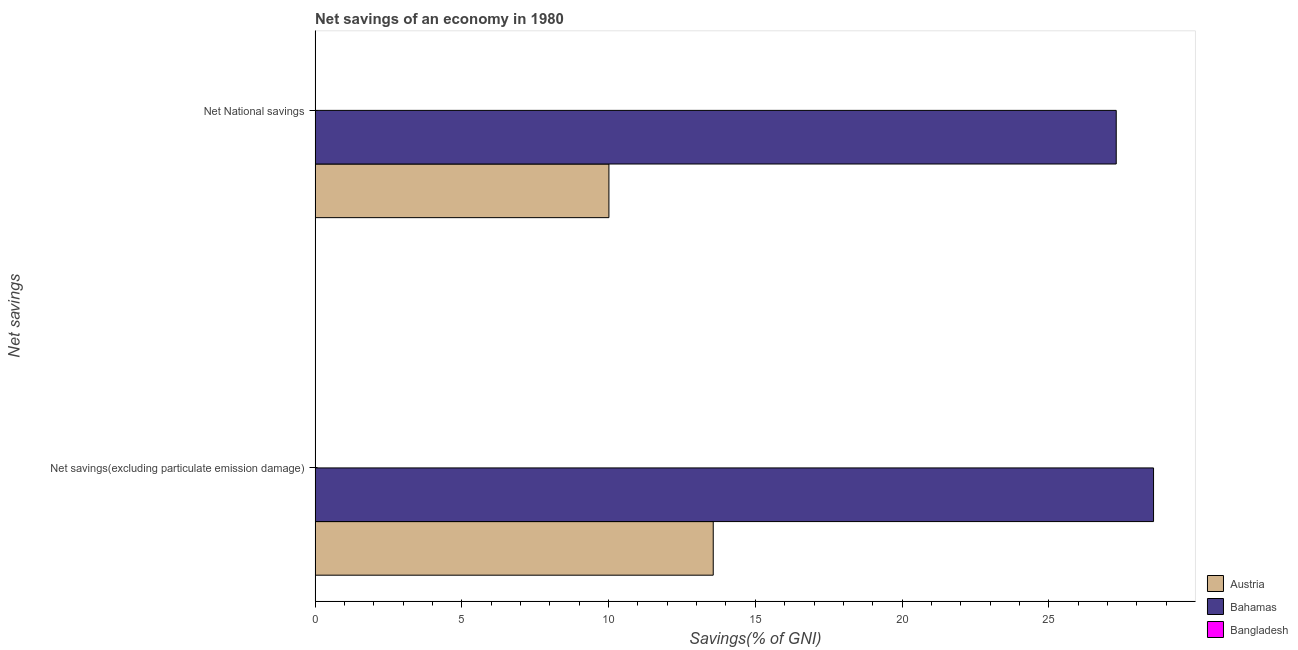Are the number of bars per tick equal to the number of legend labels?
Provide a short and direct response. No. How many bars are there on the 1st tick from the top?
Offer a terse response. 2. How many bars are there on the 1st tick from the bottom?
Your answer should be compact. 2. What is the label of the 1st group of bars from the top?
Provide a short and direct response. Net National savings. What is the net national savings in Austria?
Give a very brief answer. 10.01. Across all countries, what is the maximum net national savings?
Provide a succinct answer. 27.3. In which country was the net national savings maximum?
Your response must be concise. Bahamas. What is the total net savings(excluding particulate emission damage) in the graph?
Offer a very short reply. 42.14. What is the difference between the net national savings in Bahamas and that in Austria?
Your response must be concise. 17.29. What is the difference between the net savings(excluding particulate emission damage) in Bangladesh and the net national savings in Bahamas?
Offer a terse response. -27.3. What is the average net savings(excluding particulate emission damage) per country?
Keep it short and to the point. 14.05. What is the difference between the net savings(excluding particulate emission damage) and net national savings in Bahamas?
Your response must be concise. 1.27. What is the ratio of the net savings(excluding particulate emission damage) in Bahamas to that in Austria?
Your response must be concise. 2.11. Are all the bars in the graph horizontal?
Provide a short and direct response. Yes. How many countries are there in the graph?
Offer a very short reply. 3. What is the difference between two consecutive major ticks on the X-axis?
Provide a short and direct response. 5. Where does the legend appear in the graph?
Your response must be concise. Bottom right. How are the legend labels stacked?
Keep it short and to the point. Vertical. What is the title of the graph?
Keep it short and to the point. Net savings of an economy in 1980. What is the label or title of the X-axis?
Your response must be concise. Savings(% of GNI). What is the label or title of the Y-axis?
Keep it short and to the point. Net savings. What is the Savings(% of GNI) of Austria in Net savings(excluding particulate emission damage)?
Keep it short and to the point. 13.57. What is the Savings(% of GNI) in Bahamas in Net savings(excluding particulate emission damage)?
Your answer should be very brief. 28.57. What is the Savings(% of GNI) of Bangladesh in Net savings(excluding particulate emission damage)?
Offer a very short reply. 0. What is the Savings(% of GNI) of Austria in Net National savings?
Keep it short and to the point. 10.01. What is the Savings(% of GNI) in Bahamas in Net National savings?
Your answer should be compact. 27.3. What is the Savings(% of GNI) of Bangladesh in Net National savings?
Offer a terse response. 0. Across all Net savings, what is the maximum Savings(% of GNI) of Austria?
Your answer should be very brief. 13.57. Across all Net savings, what is the maximum Savings(% of GNI) of Bahamas?
Keep it short and to the point. 28.57. Across all Net savings, what is the minimum Savings(% of GNI) in Austria?
Provide a short and direct response. 10.01. Across all Net savings, what is the minimum Savings(% of GNI) of Bahamas?
Ensure brevity in your answer.  27.3. What is the total Savings(% of GNI) in Austria in the graph?
Make the answer very short. 23.58. What is the total Savings(% of GNI) in Bahamas in the graph?
Your response must be concise. 55.87. What is the difference between the Savings(% of GNI) of Austria in Net savings(excluding particulate emission damage) and that in Net National savings?
Give a very brief answer. 3.55. What is the difference between the Savings(% of GNI) of Bahamas in Net savings(excluding particulate emission damage) and that in Net National savings?
Your answer should be compact. 1.27. What is the difference between the Savings(% of GNI) of Austria in Net savings(excluding particulate emission damage) and the Savings(% of GNI) of Bahamas in Net National savings?
Make the answer very short. -13.73. What is the average Savings(% of GNI) in Austria per Net savings?
Your answer should be very brief. 11.79. What is the average Savings(% of GNI) of Bahamas per Net savings?
Offer a terse response. 27.93. What is the average Savings(% of GNI) in Bangladesh per Net savings?
Offer a terse response. 0. What is the difference between the Savings(% of GNI) of Austria and Savings(% of GNI) of Bahamas in Net savings(excluding particulate emission damage)?
Give a very brief answer. -15. What is the difference between the Savings(% of GNI) of Austria and Savings(% of GNI) of Bahamas in Net National savings?
Make the answer very short. -17.29. What is the ratio of the Savings(% of GNI) in Austria in Net savings(excluding particulate emission damage) to that in Net National savings?
Make the answer very short. 1.35. What is the ratio of the Savings(% of GNI) of Bahamas in Net savings(excluding particulate emission damage) to that in Net National savings?
Ensure brevity in your answer.  1.05. What is the difference between the highest and the second highest Savings(% of GNI) of Austria?
Ensure brevity in your answer.  3.55. What is the difference between the highest and the second highest Savings(% of GNI) in Bahamas?
Your response must be concise. 1.27. What is the difference between the highest and the lowest Savings(% of GNI) in Austria?
Make the answer very short. 3.55. What is the difference between the highest and the lowest Savings(% of GNI) in Bahamas?
Your answer should be very brief. 1.27. 